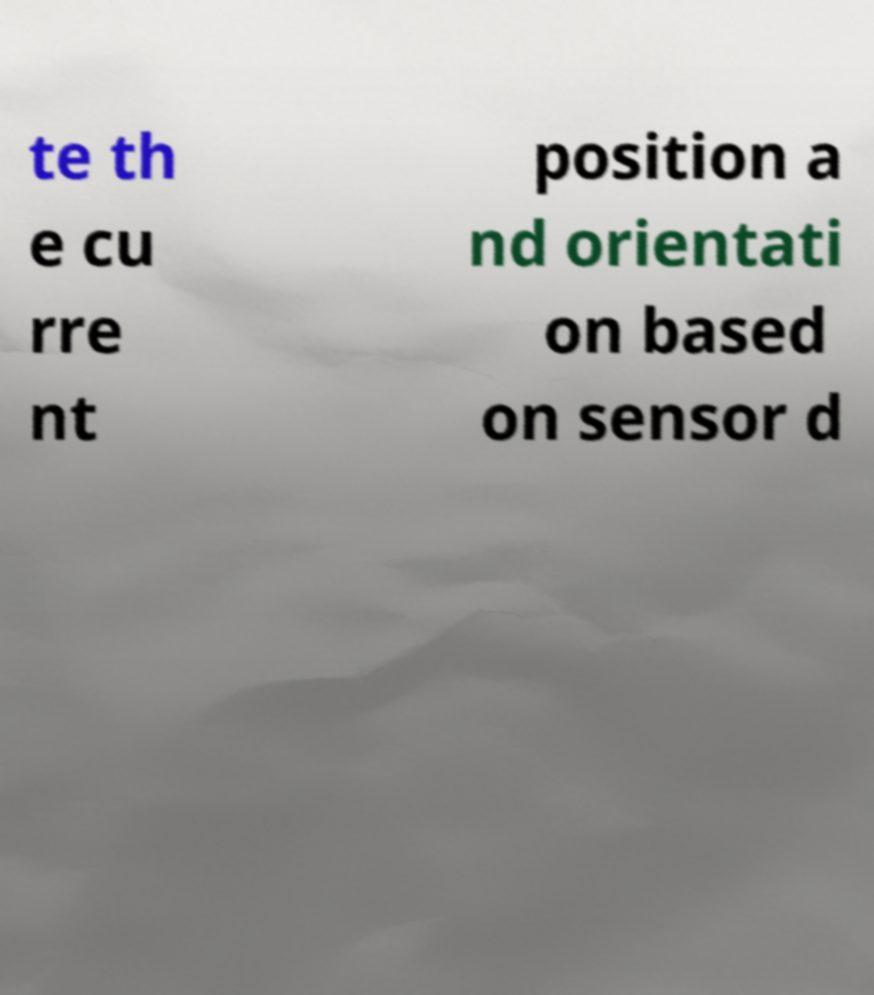Can you read and provide the text displayed in the image?This photo seems to have some interesting text. Can you extract and type it out for me? te th e cu rre nt position a nd orientati on based on sensor d 